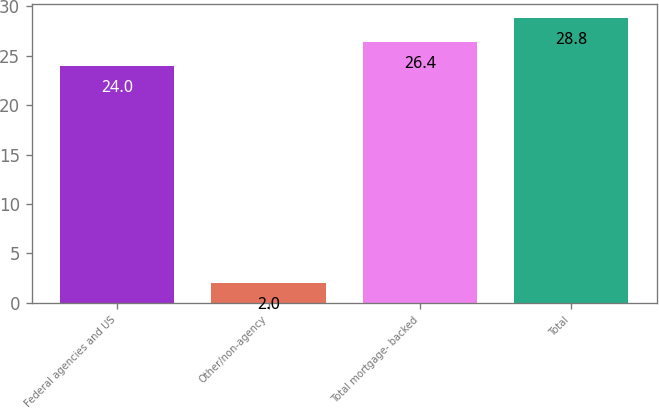Convert chart. <chart><loc_0><loc_0><loc_500><loc_500><bar_chart><fcel>Federal agencies and US<fcel>Other/non-agency<fcel>Total mortgage- backed<fcel>Total<nl><fcel>24<fcel>2<fcel>26.4<fcel>28.8<nl></chart> 